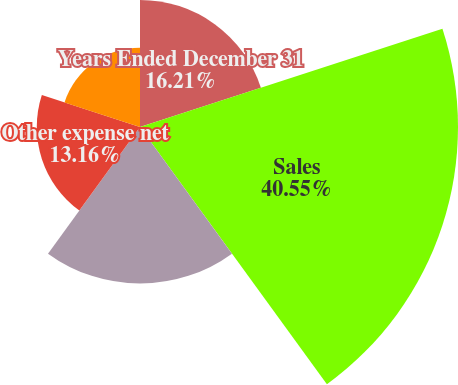Convert chart. <chart><loc_0><loc_0><loc_500><loc_500><pie_chart><fcel>Years Ended December 31<fcel>Sales<fcel>Materials and production costs<fcel>Other expense net<fcel>Income before taxes<nl><fcel>16.21%<fcel>40.55%<fcel>19.96%<fcel>13.16%<fcel>10.12%<nl></chart> 